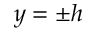<formula> <loc_0><loc_0><loc_500><loc_500>y = \pm h</formula> 